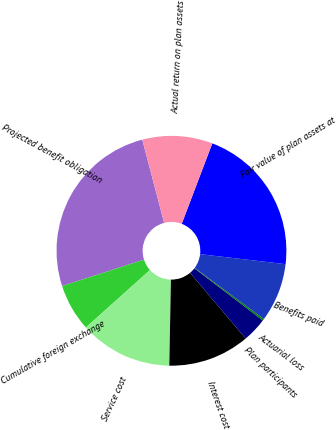<chart> <loc_0><loc_0><loc_500><loc_500><pie_chart><fcel>Projected benefit obligation<fcel>Cumulative foreign exchange<fcel>Service cost<fcel>Interest cost<fcel>Plan participants<fcel>Actuarial loss<fcel>Benefits paid<fcel>Fair value of plan assets at<fcel>Actual return on plan assets<nl><fcel>25.88%<fcel>6.66%<fcel>13.07%<fcel>11.47%<fcel>3.46%<fcel>0.25%<fcel>8.26%<fcel>21.08%<fcel>9.87%<nl></chart> 